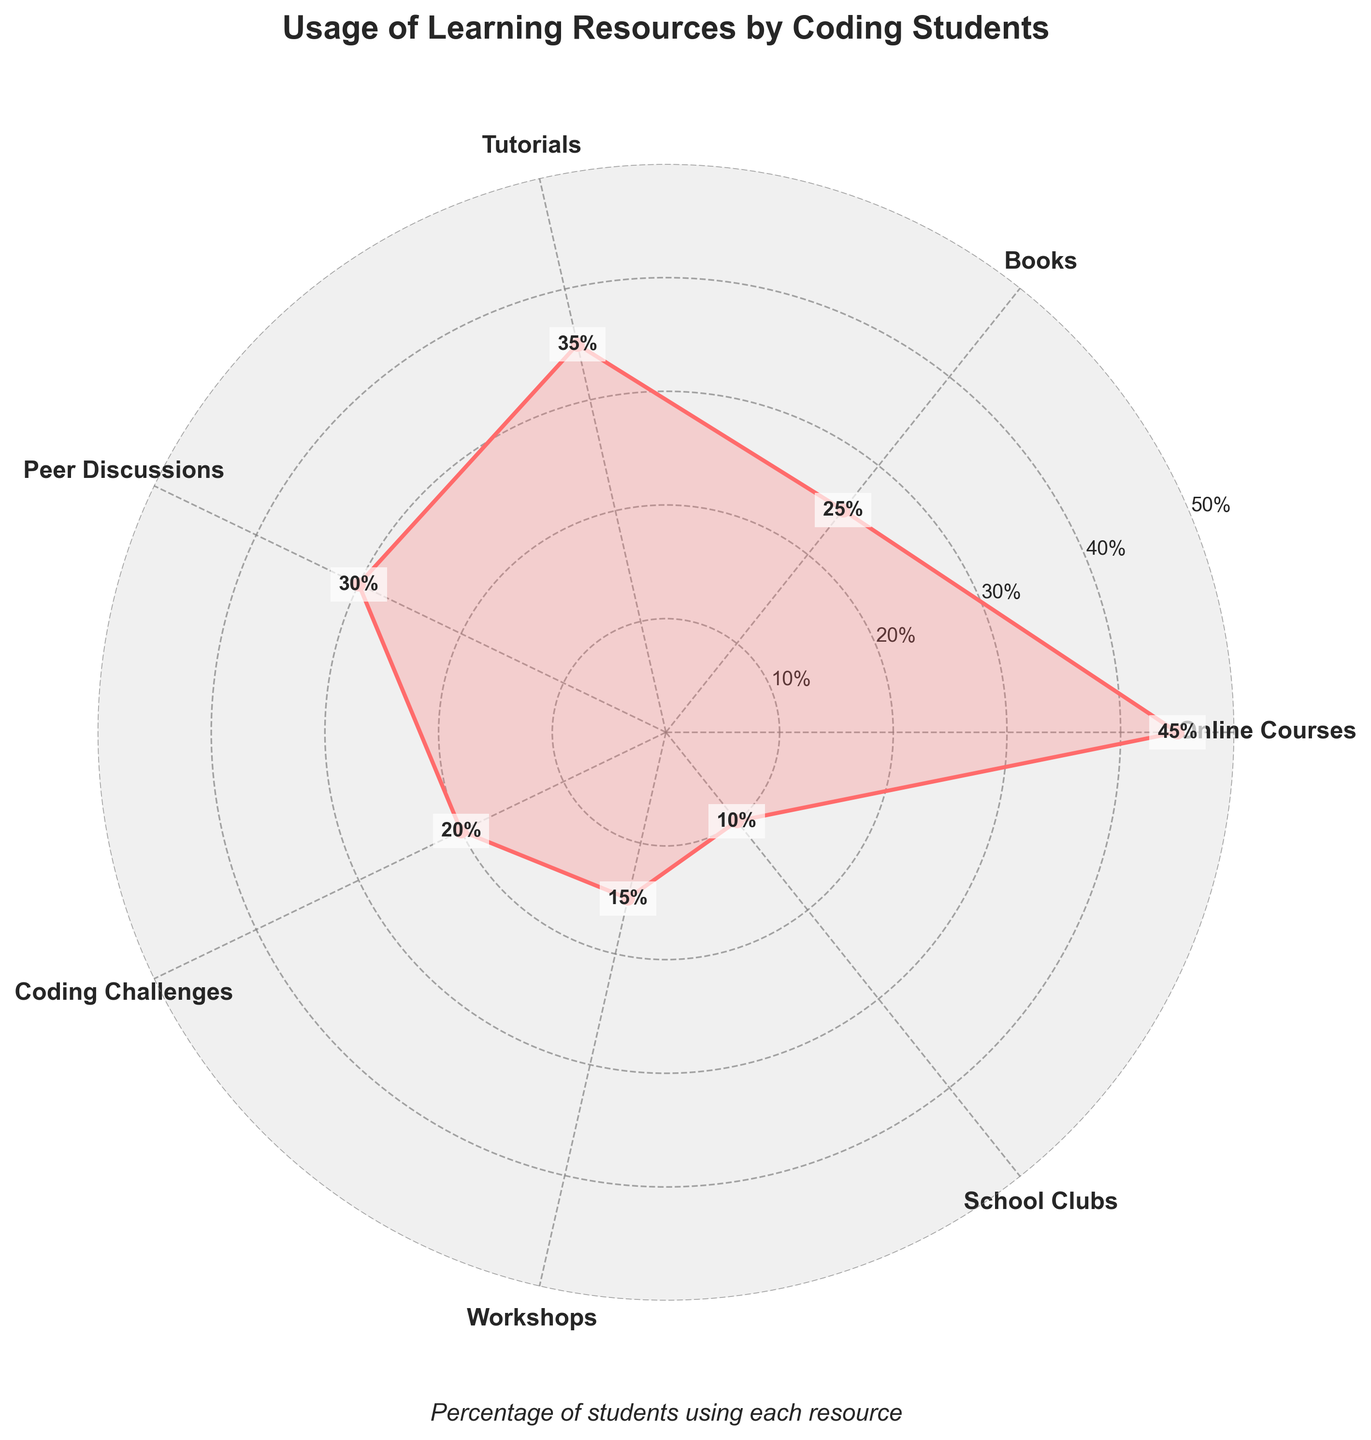Which learning resource is used by the highest percentage of high school students? The figure shows that the highest point on the radar chart is for Online Courses at 45%.
Answer: Online Courses Which two learning resources have the closest usage percentages? From the figure, Tutorials (35%) and Peer Discussions (30%) have the closest usage percentages, being within 5% of each other.
Answer: Tutorials and Peer Discussions What is the total percentage of students using Online Courses, Books, and Peer Discussions combined? The individual usage percentages are 45% for Online Courses, 25% for Books, and 30% for Peer Discussions. Adding these percentages together gives 45 + 25 + 30 = 100%.
Answer: 100% Which learning resource is used the least by high school students? The radar chart shows the lowest point for School Clubs at 10%.
Answer: School Clubs Compare the usage of Coding Challenges to Workshops. Which one is higher and by how much? The figure shows Coding Challenges at 20% and Workshops at 15%. Coding Challenges are higher by 20 - 15 = 5%.
Answer: Coding Challenges by 5% What is the average percentage usage of Books, Tutorials, and Coding Challenges? The individual percentages are 25% for Books, 35% for Tutorials, and 20% for Coding Challenges. The sum of these is 25 + 35 + 20 = 80. Dividing by 3, the average is 80 / 3 ≈ 26.67%.
Answer: 26.67% What is the difference in usage percentage between the highest and lowest used learning resources? The highest usage is for Online Courses at 45%, and the lowest is for School Clubs at 10%. The difference is 45 - 10 = 35%.
Answer: 35% How many learning resources have a usage percentage of 30% or higher? From the radar chart, the resources with usage percentages of 30% or higher are Online Courses (45%), Tutorials (35%), and Peer Discussions (30%). This totals to 3 resources.
Answer: 3 Is the percentage of students using Workshops greater than half of those using Tutorials? The figure shows 35% for Tutorials and 15% for Workshops. Half of Tutorials is 35 / 2 = 17.5%, and since 15% < 17.5%, Workshops are not used more than half of Tutorials.
Answer: No In what order do the learning resources appear in a clockwise direction starting from Online Courses? The radar chart positions the resources starting from Online Courses in the following order: Online Courses, Books, Tutorials, Peer Discussions, Coding Challenges, Workshops, School Clubs.
Answer: Online Courses, Books, Tutorials, Peer Discussions, Coding Challenges, Workshops, School Clubs 